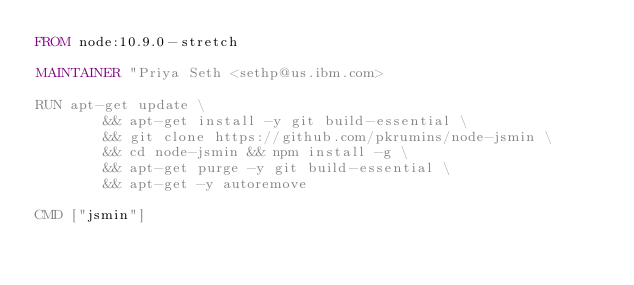<code> <loc_0><loc_0><loc_500><loc_500><_Dockerfile_>FROM node:10.9.0-stretch

MAINTAINER "Priya Seth <sethp@us.ibm.com>

RUN apt-get update \
        && apt-get install -y git build-essential \
        && git clone https://github.com/pkrumins/node-jsmin \
        && cd node-jsmin && npm install -g \
        && apt-get purge -y git build-essential \
        && apt-get -y autoremove

CMD ["jsmin"]
</code> 